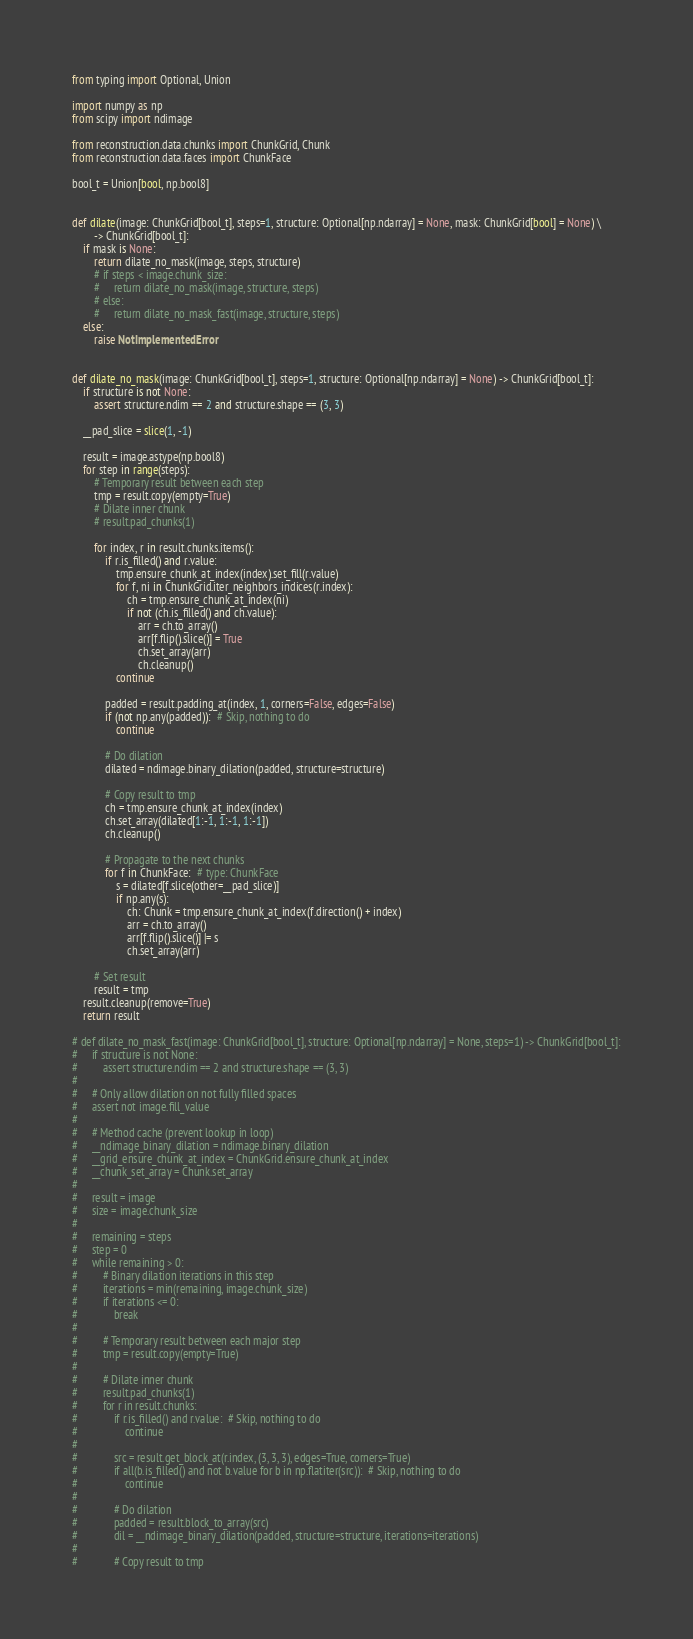Convert code to text. <code><loc_0><loc_0><loc_500><loc_500><_Python_>from typing import Optional, Union

import numpy as np
from scipy import ndimage

from reconstruction.data.chunks import ChunkGrid, Chunk
from reconstruction.data.faces import ChunkFace

bool_t = Union[bool, np.bool8]


def dilate(image: ChunkGrid[bool_t], steps=1, structure: Optional[np.ndarray] = None, mask: ChunkGrid[bool] = None) \
        -> ChunkGrid[bool_t]:
    if mask is None:
        return dilate_no_mask(image, steps, structure)
        # if steps < image.chunk_size:
        #     return dilate_no_mask(image, structure, steps)
        # else:
        #     return dilate_no_mask_fast(image, structure, steps)
    else:
        raise NotImplementedError


def dilate_no_mask(image: ChunkGrid[bool_t], steps=1, structure: Optional[np.ndarray] = None) -> ChunkGrid[bool_t]:
    if structure is not None:
        assert structure.ndim == 2 and structure.shape == (3, 3)

    __pad_slice = slice(1, -1)

    result = image.astype(np.bool8)
    for step in range(steps):
        # Temporary result between each step
        tmp = result.copy(empty=True)
        # Dilate inner chunk
        # result.pad_chunks(1)

        for index, r in result.chunks.items():
            if r.is_filled() and r.value:
                tmp.ensure_chunk_at_index(index).set_fill(r.value)
                for f, ni in ChunkGrid.iter_neighbors_indices(r.index):
                    ch = tmp.ensure_chunk_at_index(ni)
                    if not (ch.is_filled() and ch.value):
                        arr = ch.to_array()
                        arr[f.flip().slice()] = True
                        ch.set_array(arr)
                        ch.cleanup()
                continue

            padded = result.padding_at(index, 1, corners=False, edges=False)
            if (not np.any(padded)):  # Skip, nothing to do
                continue

            # Do dilation
            dilated = ndimage.binary_dilation(padded, structure=structure)

            # Copy result to tmp
            ch = tmp.ensure_chunk_at_index(index)
            ch.set_array(dilated[1:-1, 1:-1, 1:-1])
            ch.cleanup()

            # Propagate to the next chunks
            for f in ChunkFace:  # type: ChunkFace
                s = dilated[f.slice(other=__pad_slice)]
                if np.any(s):
                    ch: Chunk = tmp.ensure_chunk_at_index(f.direction() + index)
                    arr = ch.to_array()
                    arr[f.flip().slice()] |= s
                    ch.set_array(arr)

        # Set result
        result = tmp
    result.cleanup(remove=True)
    return result

# def dilate_no_mask_fast(image: ChunkGrid[bool_t], structure: Optional[np.ndarray] = None, steps=1) -> ChunkGrid[bool_t]:
#     if structure is not None:
#         assert structure.ndim == 2 and structure.shape == (3, 3)
#
#     # Only allow dilation on not fully filled spaces
#     assert not image.fill_value
#
#     # Method cache (prevent lookup in loop)
#     __ndimage_binary_dilation = ndimage.binary_dilation
#     __grid_ensure_chunk_at_index = ChunkGrid.ensure_chunk_at_index
#     __chunk_set_array = Chunk.set_array
#
#     result = image
#     size = image.chunk_size
#
#     remaining = steps
#     step = 0
#     while remaining > 0:
#         # Binary dilation iterations in this step
#         iterations = min(remaining, image.chunk_size)
#         if iterations <= 0:
#             break
#
#         # Temporary result between each major step
#         tmp = result.copy(empty=True)
#
#         # Dilate inner chunk
#         result.pad_chunks(1)
#         for r in result.chunks:
#             if r.is_filled() and r.value:  # Skip, nothing to do
#                 continue
#
#             src = result.get_block_at(r.index, (3, 3, 3), edges=True, corners=True)
#             if all(b.is_filled() and not b.value for b in np.flatiter(src)):  # Skip, nothing to do
#                 continue
#
#             # Do dilation
#             padded = result.block_to_array(src)
#             dil = __ndimage_binary_dilation(padded, structure=structure, iterations=iterations)
#
#             # Copy result to tmp</code> 